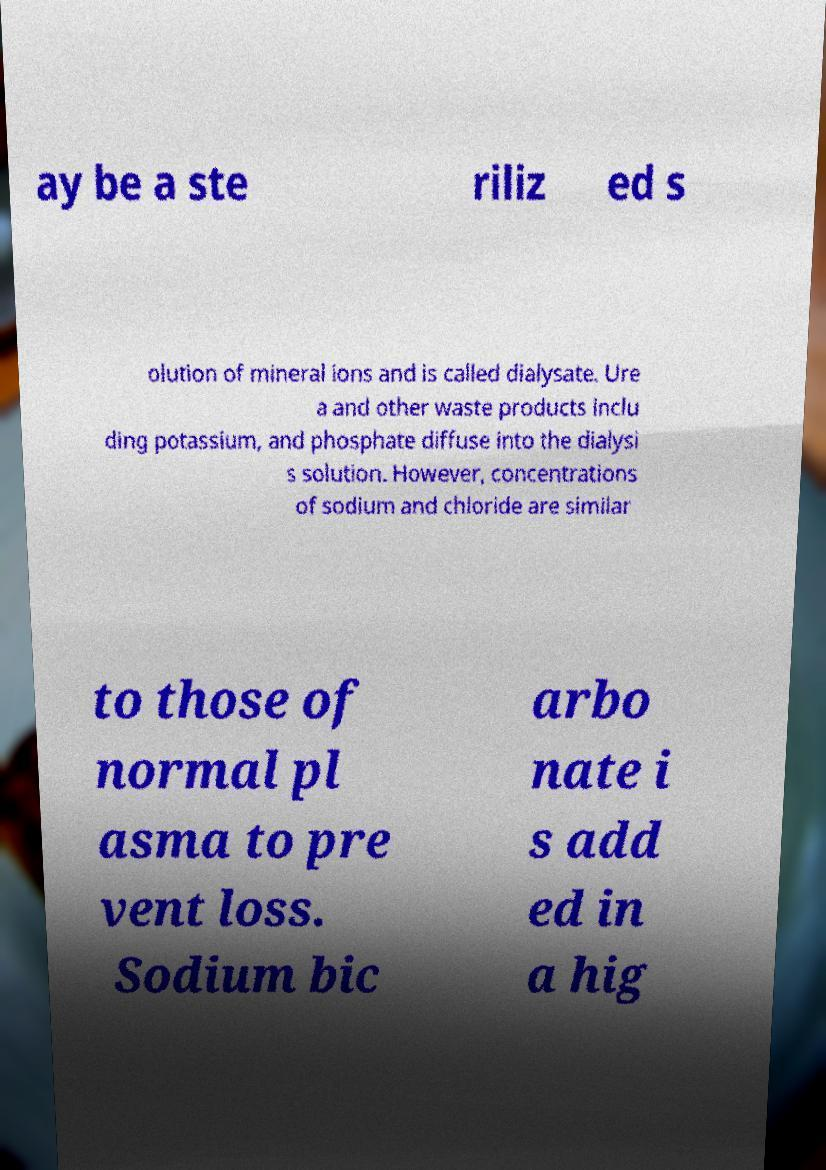For documentation purposes, I need the text within this image transcribed. Could you provide that? ay be a ste riliz ed s olution of mineral ions and is called dialysate. Ure a and other waste products inclu ding potassium, and phosphate diffuse into the dialysi s solution. However, concentrations of sodium and chloride are similar to those of normal pl asma to pre vent loss. Sodium bic arbo nate i s add ed in a hig 